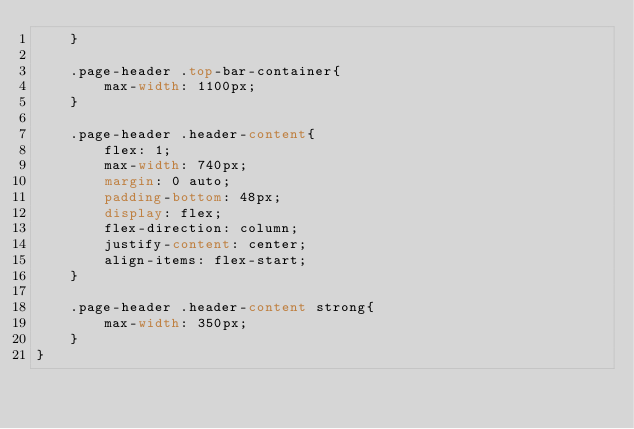Convert code to text. <code><loc_0><loc_0><loc_500><loc_500><_CSS_>    }

    .page-header .top-bar-container{
        max-width: 1100px;
    }

    .page-header .header-content{
        flex: 1;
        max-width: 740px;
        margin: 0 auto;
        padding-bottom: 48px;
        display: flex;
        flex-direction: column;
        justify-content: center;
        align-items: flex-start;
    }

    .page-header .header-content strong{
        max-width: 350px;
    }
}</code> 